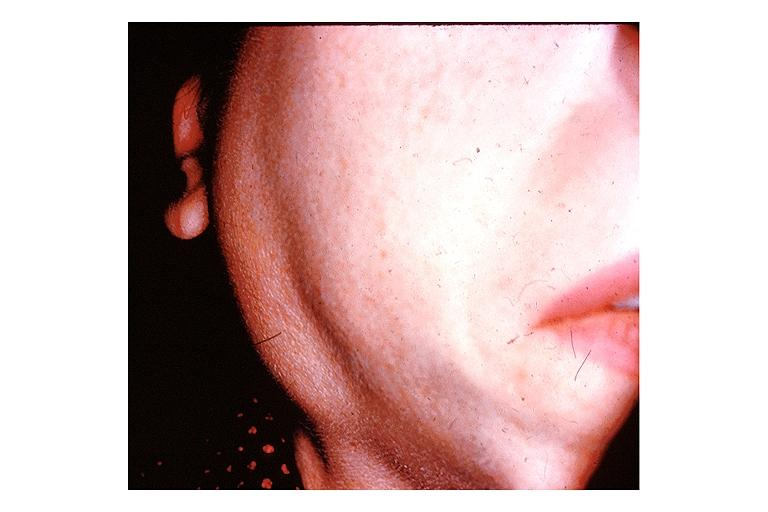s oral present?
Answer the question using a single word or phrase. Yes 